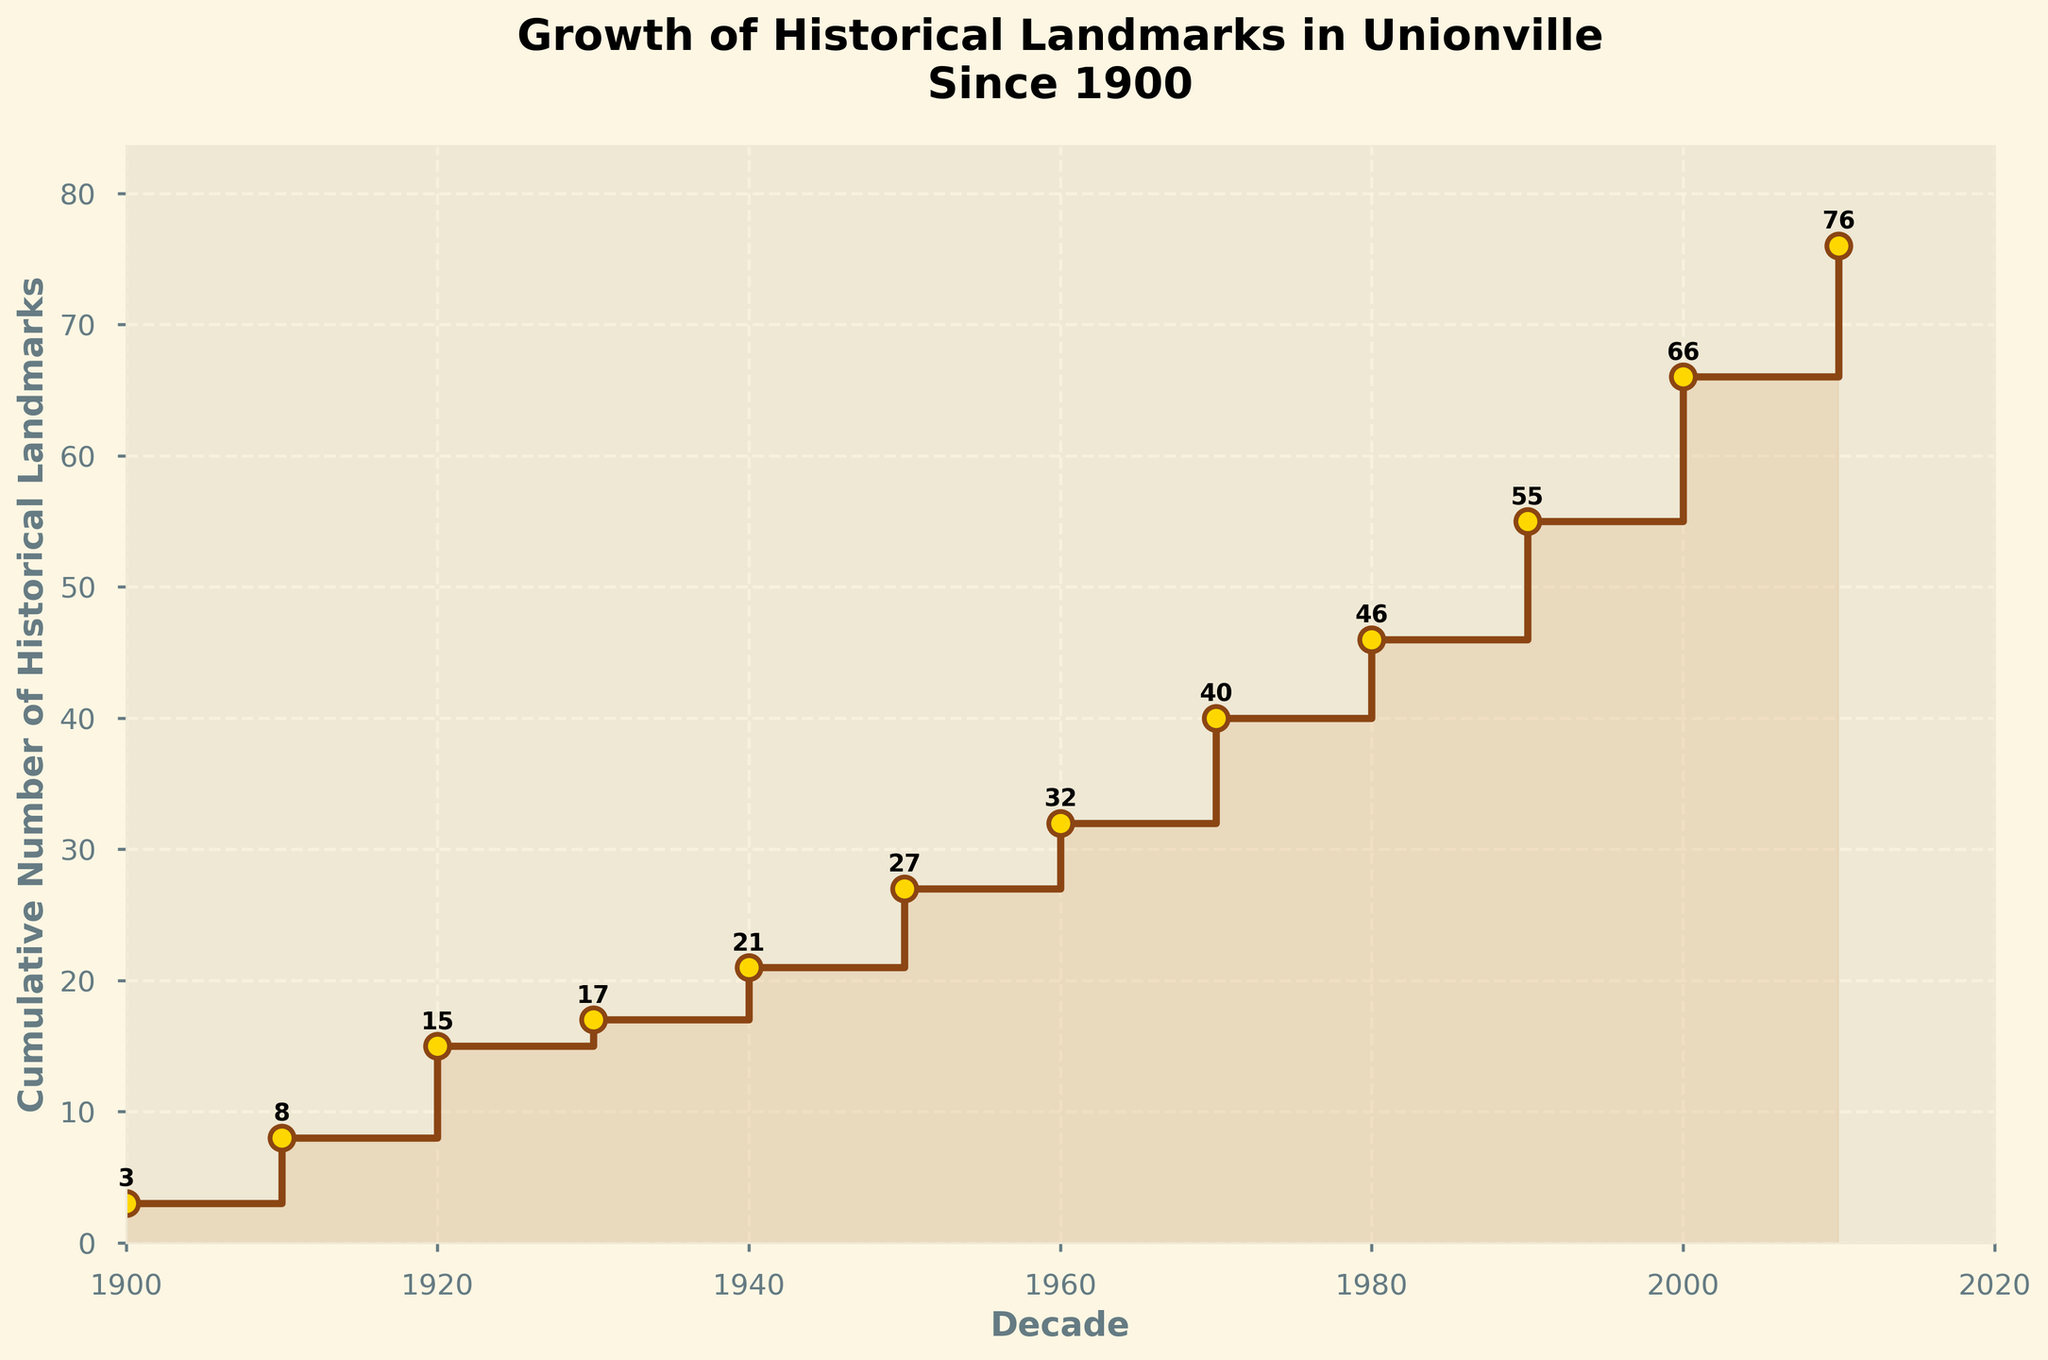How many historical landmarks were added in Unionville in the 1910s? According to the plot, the y-value increases from 3 to 8 in the 1910s. The difference 8 - 3 gives the number of landmarks added.
Answer: 5 What is the cumulative number of historical landmarks by the end of the 1950s? At the end of the 1950s, the plot shows the cumulative number at the y-axis value corresponding to the 1950s, which is 27.
Answer: 27 During which decade did Unionville see the highest number of historical landmarks added? The step size in the 2000s is the greatest. The cumulative count rises from 45 to 56 which means 11 landmarks were added, the highest of any decade.
Answer: 2000s How many total historical landmarks were added in the first half of the 20th century (1900-1950s)? Add the number of landmarks added from 1900s to 1950s: 3 + 5 + 7 + 2 + 4 + 6 = 27.
Answer: 27 Compare the number of historical landmarks added in the 1970s to the 1980s. Which decade had more? In the 1970s, 8 landmarks were added, while in the 1980s, 6 landmarks were added. Comparing the two, 8 is greater than 6.
Answer: 1970s What is the trend in the cumulative number of historical landmarks over the decades? The cumulative number of historical landmarks increases over the decades, with occasional larger increments in certain decades like the 2000s and 2010s.
Answer: Increasing What is the percentage increase in the number of landmarks added from the 1940s to the 1950s? The 1940s saw 4 landmarks added, and the 1950s saw 6. The percentage increase is: ((6-4) / 4) * 100% = 50%.
Answer: 50% What is the cumulative number of historical landmarks at the start of the 2000s? At the start of the 2000s, looking at the end of the 1990s, the cumulative number is 45.
Answer: 45 Was there any decade where the number of landmarks added was less than the previous decade? Yes, specifically in the 1930s, where only 2 landmarks were added compared to 7 in the 1920s.
Answer: 1930s What is the cumulative growth differential between the 2000s and 2010s? The cumulative number in the 2000s is 56 and in the 2010s is 66. The growth differential is 66 - 56 = 10.
Answer: 10 